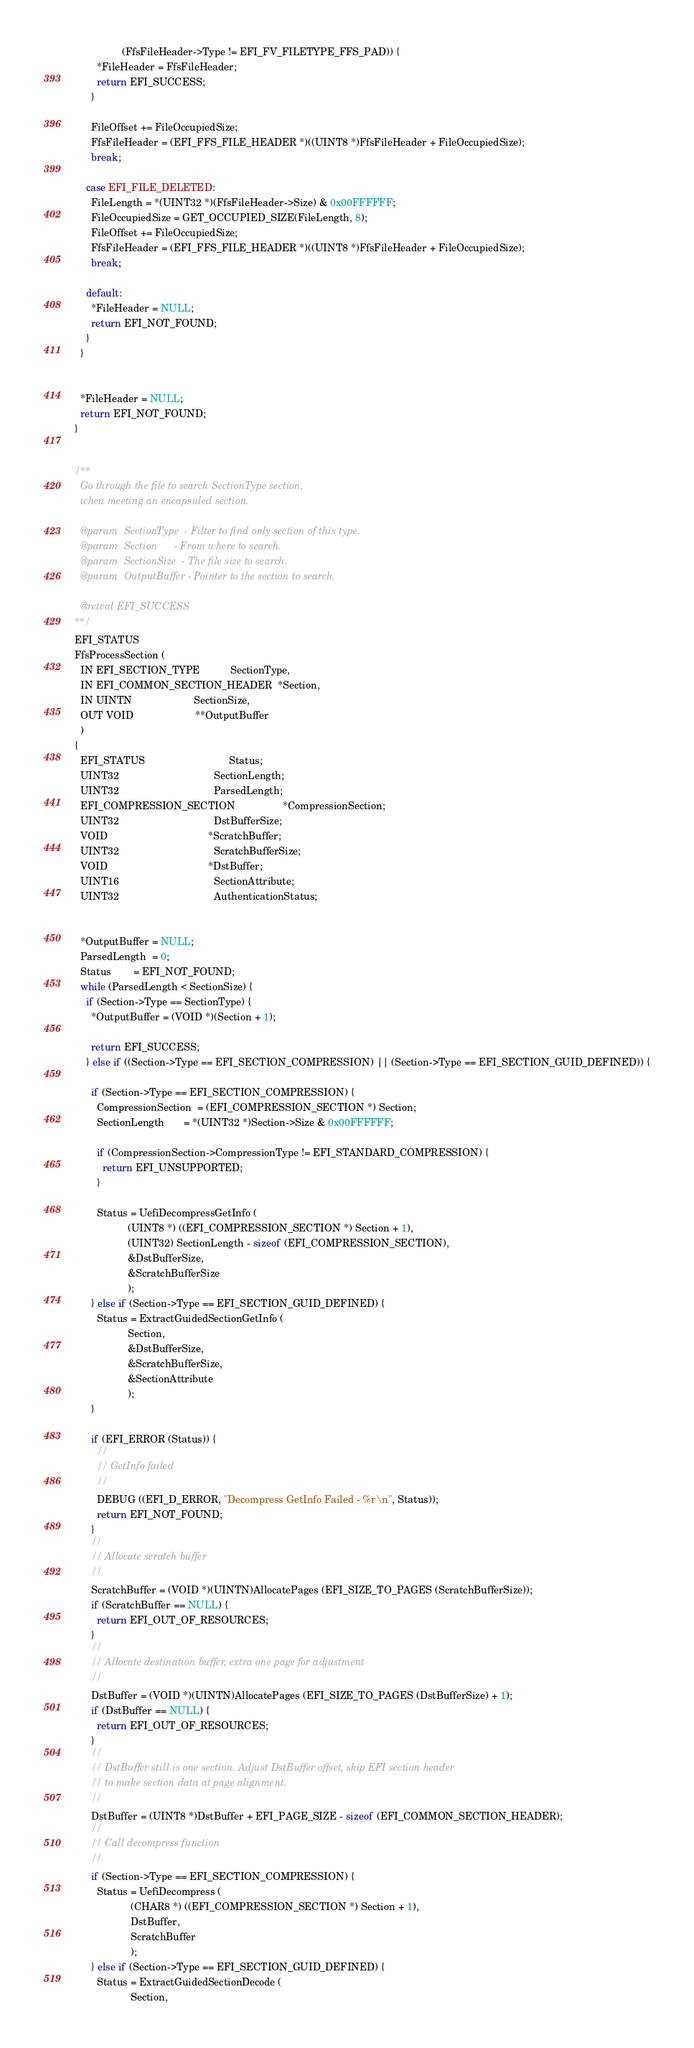<code> <loc_0><loc_0><loc_500><loc_500><_C_>                 (FfsFileHeader->Type != EFI_FV_FILETYPE_FFS_PAD)) {
        *FileHeader = FfsFileHeader;
        return EFI_SUCCESS;
      }

      FileOffset += FileOccupiedSize;
      FfsFileHeader = (EFI_FFS_FILE_HEADER *)((UINT8 *)FfsFileHeader + FileOccupiedSize);
      break;

    case EFI_FILE_DELETED:
      FileLength = *(UINT32 *)(FfsFileHeader->Size) & 0x00FFFFFF;
      FileOccupiedSize = GET_OCCUPIED_SIZE(FileLength, 8);
      FileOffset += FileOccupiedSize;
      FfsFileHeader = (EFI_FFS_FILE_HEADER *)((UINT8 *)FfsFileHeader + FileOccupiedSize);
      break;

    default:
      *FileHeader = NULL;
      return EFI_NOT_FOUND;
    }
  }


  *FileHeader = NULL;
  return EFI_NOT_FOUND;
}


/**
  Go through the file to search SectionType section,
  when meeting an encapsuled section.

  @param  SectionType  - Filter to find only section of this type.
  @param  Section      - From where to search.
  @param  SectionSize  - The file size to search.
  @param  OutputBuffer - Pointer to the section to search.

  @retval EFI_SUCCESS
**/
EFI_STATUS
FfsProcessSection (
  IN EFI_SECTION_TYPE           SectionType,
  IN EFI_COMMON_SECTION_HEADER  *Section,
  IN UINTN                      SectionSize,
  OUT VOID                      **OutputBuffer
  )
{
  EFI_STATUS                              Status;
  UINT32                                  SectionLength;
  UINT32                                  ParsedLength;
  EFI_COMPRESSION_SECTION                 *CompressionSection;
  UINT32                                  DstBufferSize;
  VOID                                    *ScratchBuffer;
  UINT32                                  ScratchBufferSize;
  VOID                                    *DstBuffer;
  UINT16                                  SectionAttribute;
  UINT32                                  AuthenticationStatus;


  *OutputBuffer = NULL;
  ParsedLength  = 0;
  Status        = EFI_NOT_FOUND;
  while (ParsedLength < SectionSize) {
    if (Section->Type == SectionType) {
      *OutputBuffer = (VOID *)(Section + 1);

      return EFI_SUCCESS;
    } else if ((Section->Type == EFI_SECTION_COMPRESSION) || (Section->Type == EFI_SECTION_GUID_DEFINED)) {

      if (Section->Type == EFI_SECTION_COMPRESSION) {
        CompressionSection  = (EFI_COMPRESSION_SECTION *) Section;
        SectionLength       = *(UINT32 *)Section->Size & 0x00FFFFFF;

        if (CompressionSection->CompressionType != EFI_STANDARD_COMPRESSION) {
          return EFI_UNSUPPORTED;
        }

        Status = UefiDecompressGetInfo (
                   (UINT8 *) ((EFI_COMPRESSION_SECTION *) Section + 1),
                   (UINT32) SectionLength - sizeof (EFI_COMPRESSION_SECTION),
                   &DstBufferSize,
                   &ScratchBufferSize
                   );
      } else if (Section->Type == EFI_SECTION_GUID_DEFINED) {
        Status = ExtractGuidedSectionGetInfo (
                   Section,
                   &DstBufferSize,
                   &ScratchBufferSize,
                   &SectionAttribute
                   );
      }

      if (EFI_ERROR (Status)) {
        //
        // GetInfo failed
        //
        DEBUG ((EFI_D_ERROR, "Decompress GetInfo Failed - %r\n", Status));
        return EFI_NOT_FOUND;
      }
      //
      // Allocate scratch buffer
      //
      ScratchBuffer = (VOID *)(UINTN)AllocatePages (EFI_SIZE_TO_PAGES (ScratchBufferSize));
      if (ScratchBuffer == NULL) {
        return EFI_OUT_OF_RESOURCES;
      }
      //
      // Allocate destination buffer, extra one page for adjustment
      //
      DstBuffer = (VOID *)(UINTN)AllocatePages (EFI_SIZE_TO_PAGES (DstBufferSize) + 1);
      if (DstBuffer == NULL) {
        return EFI_OUT_OF_RESOURCES;
      }
      //
      // DstBuffer still is one section. Adjust DstBuffer offset, skip EFI section header
      // to make section data at page alignment.
      //
      DstBuffer = (UINT8 *)DstBuffer + EFI_PAGE_SIZE - sizeof (EFI_COMMON_SECTION_HEADER);
      //
      // Call decompress function
      //
      if (Section->Type == EFI_SECTION_COMPRESSION) {
        Status = UefiDecompress (
                    (CHAR8 *) ((EFI_COMPRESSION_SECTION *) Section + 1),
                    DstBuffer,
                    ScratchBuffer
                    );
      } else if (Section->Type == EFI_SECTION_GUID_DEFINED) {
        Status = ExtractGuidedSectionDecode (
                    Section,</code> 